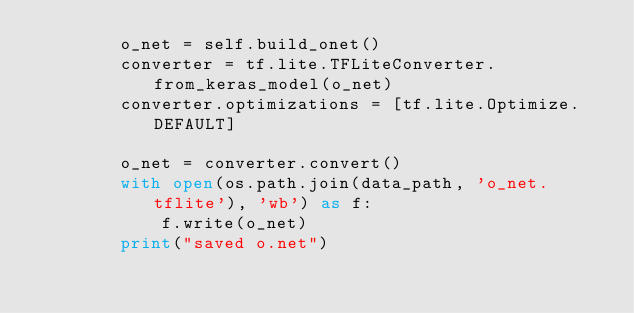<code> <loc_0><loc_0><loc_500><loc_500><_Python_>        o_net = self.build_onet()
        converter = tf.lite.TFLiteConverter.from_keras_model(o_net)
        converter.optimizations = [tf.lite.Optimize.DEFAULT]

        o_net = converter.convert()
        with open(os.path.join(data_path, 'o_net.tflite'), 'wb') as f:
            f.write(o_net)
        print("saved o.net")</code> 